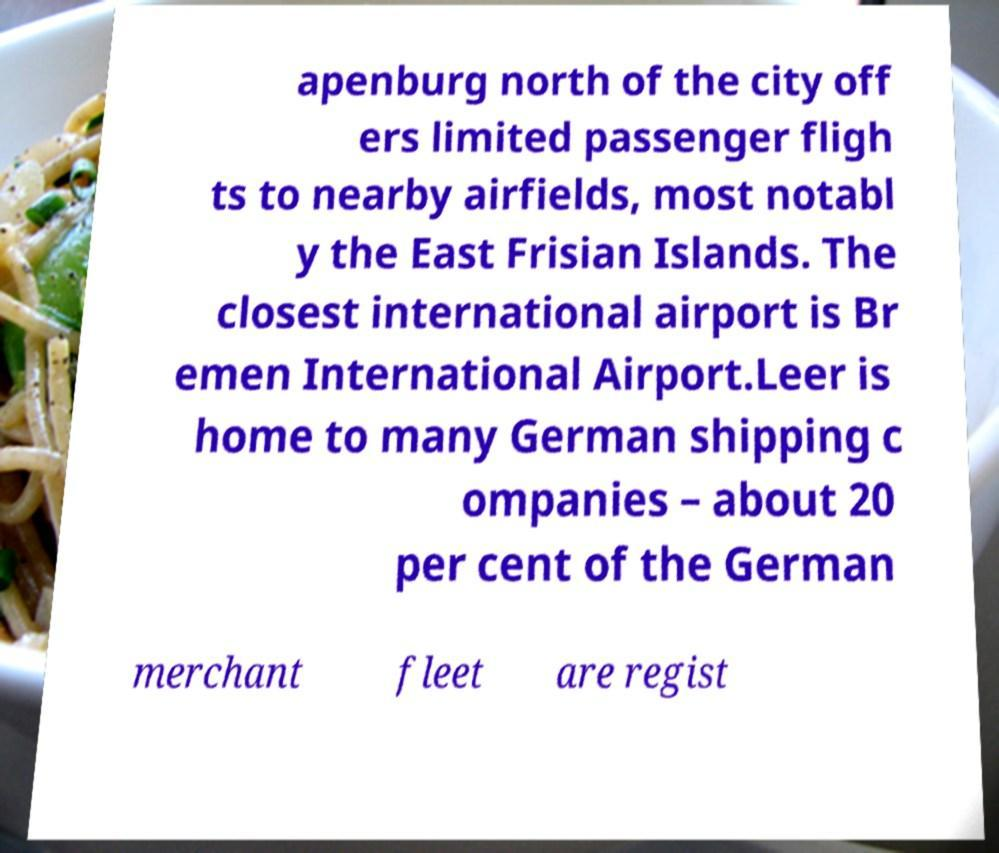Can you read and provide the text displayed in the image?This photo seems to have some interesting text. Can you extract and type it out for me? apenburg north of the city off ers limited passenger fligh ts to nearby airfields, most notabl y the East Frisian Islands. The closest international airport is Br emen International Airport.Leer is home to many German shipping c ompanies – about 20 per cent of the German merchant fleet are regist 